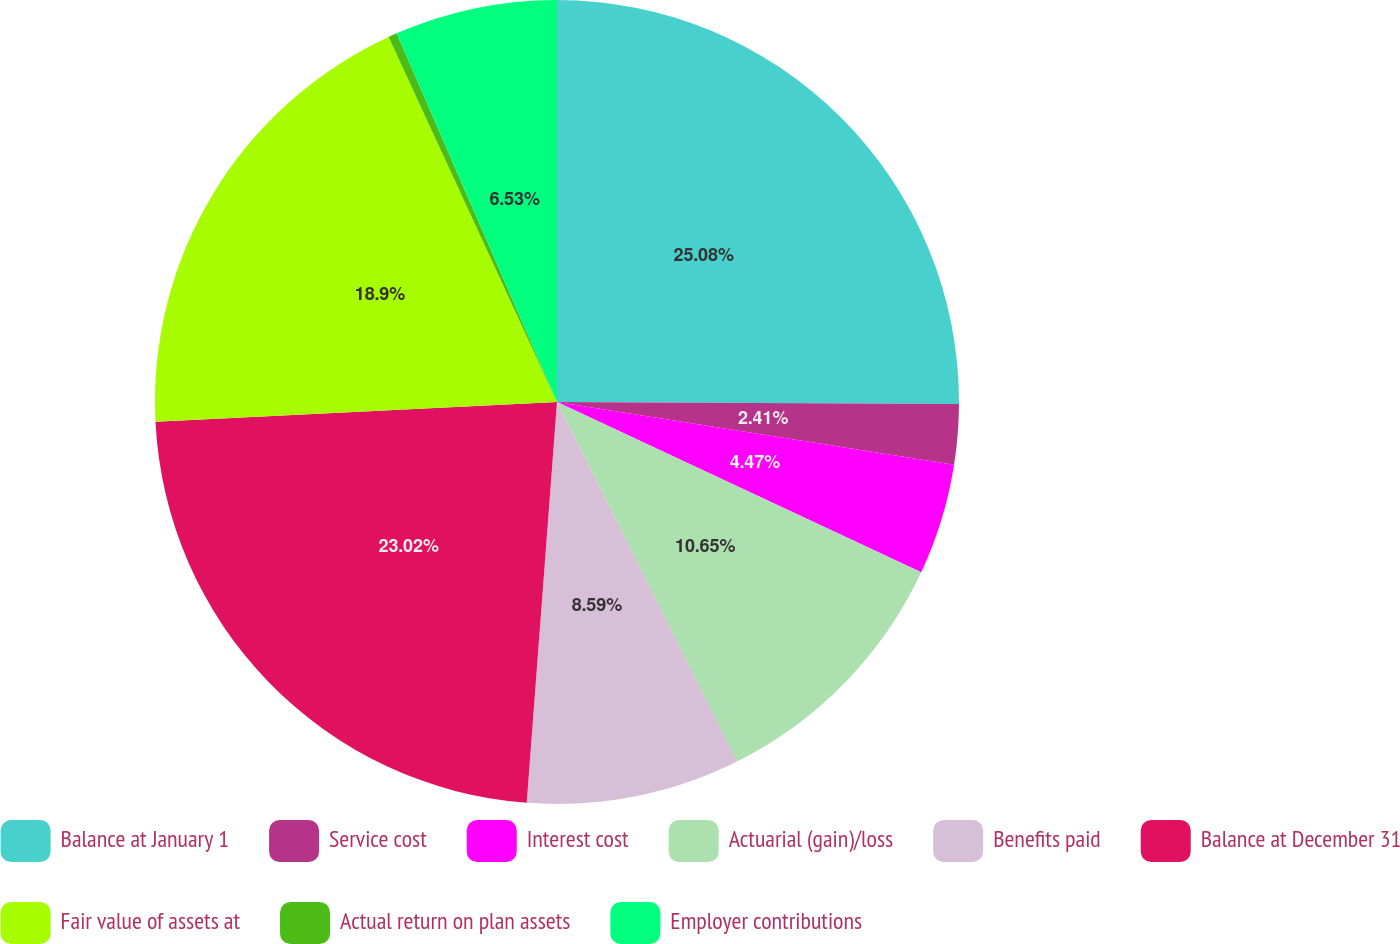<chart> <loc_0><loc_0><loc_500><loc_500><pie_chart><fcel>Balance at January 1<fcel>Service cost<fcel>Interest cost<fcel>Actuarial (gain)/loss<fcel>Benefits paid<fcel>Balance at December 31<fcel>Fair value of assets at<fcel>Actual return on plan assets<fcel>Employer contributions<nl><fcel>25.08%<fcel>2.41%<fcel>4.47%<fcel>10.65%<fcel>8.59%<fcel>23.02%<fcel>18.9%<fcel>0.35%<fcel>6.53%<nl></chart> 